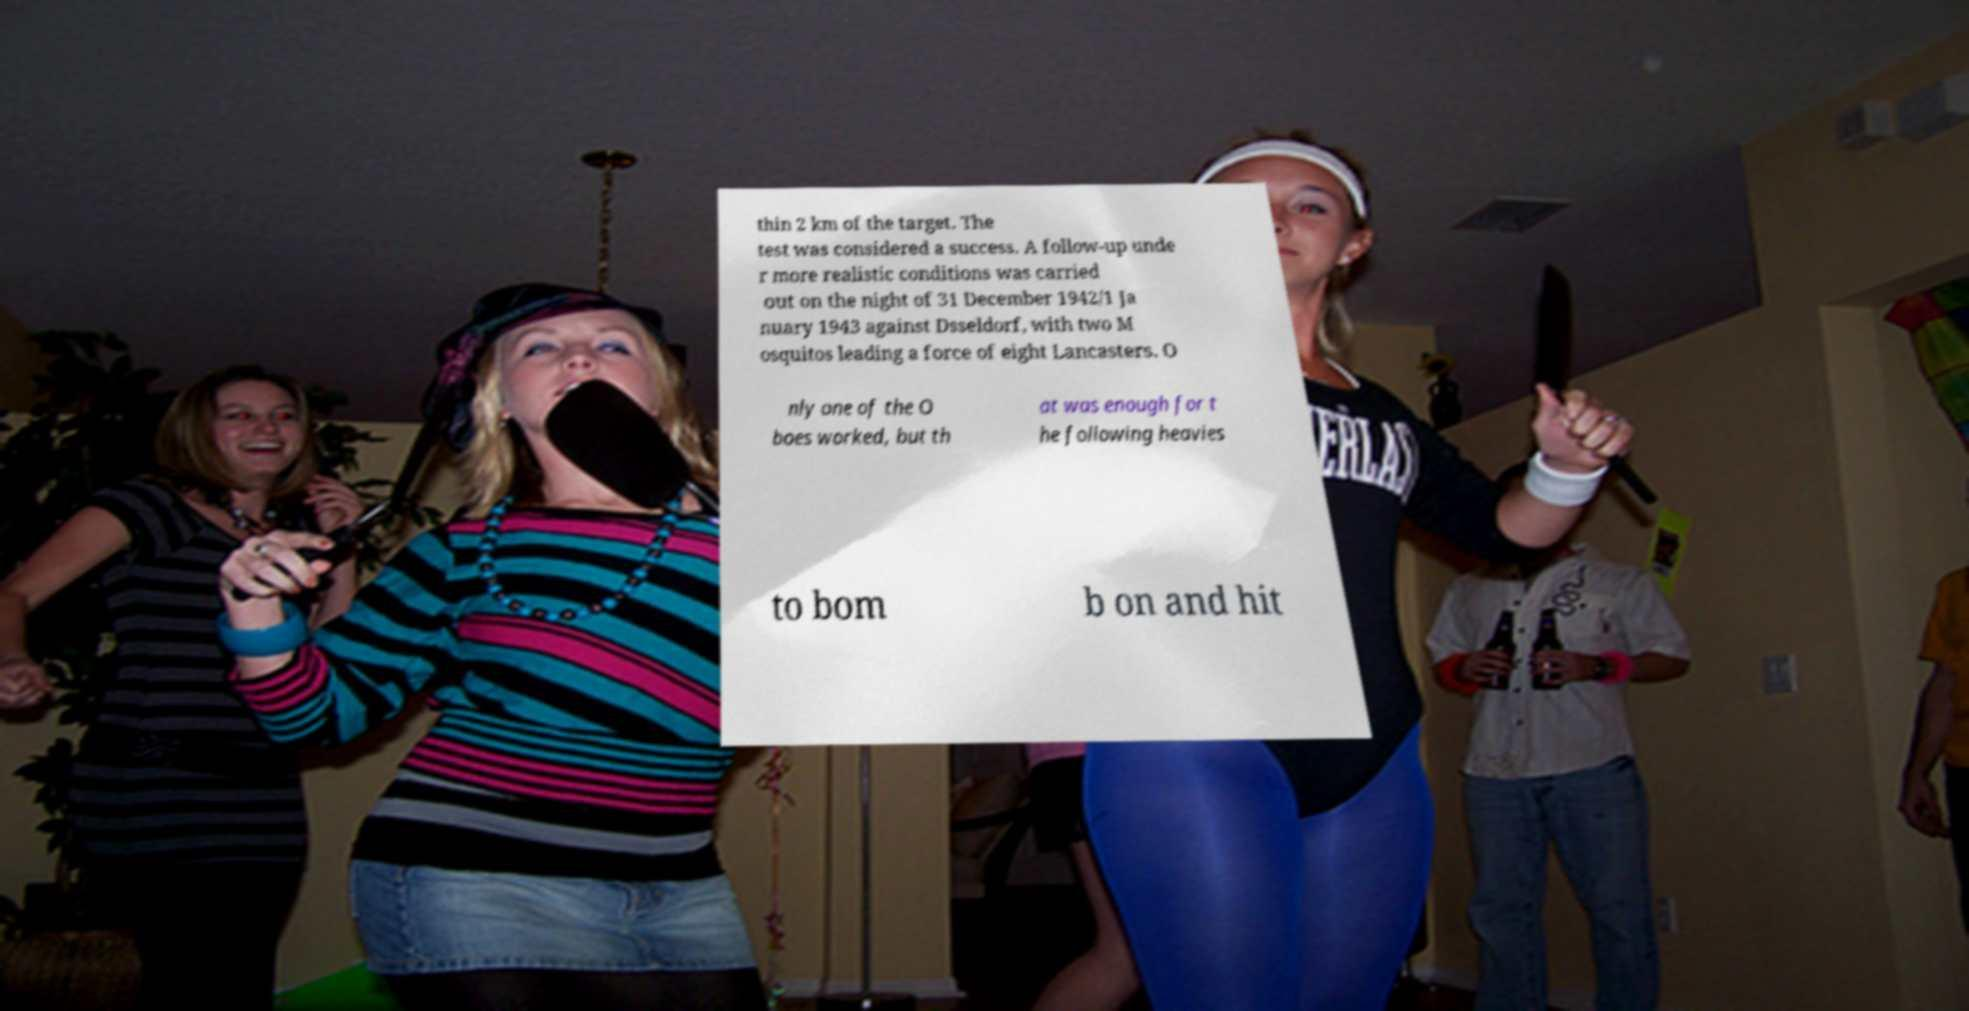What messages or text are displayed in this image? I need them in a readable, typed format. thin 2 km of the target. The test was considered a success. A follow-up unde r more realistic conditions was carried out on the night of 31 December 1942/1 Ja nuary 1943 against Dsseldorf, with two M osquitos leading a force of eight Lancasters. O nly one of the O boes worked, but th at was enough for t he following heavies to bom b on and hit 